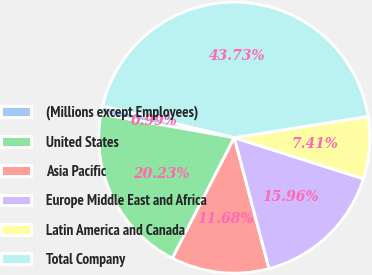Convert chart. <chart><loc_0><loc_0><loc_500><loc_500><pie_chart><fcel>(Millions except Employees)<fcel>United States<fcel>Asia Pacific<fcel>Europe Middle East and Africa<fcel>Latin America and Canada<fcel>Total Company<nl><fcel>0.99%<fcel>20.23%<fcel>11.68%<fcel>15.96%<fcel>7.41%<fcel>43.73%<nl></chart> 